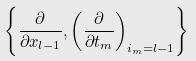<formula> <loc_0><loc_0><loc_500><loc_500>\left \{ \frac { \partial } { \partial x _ { l - 1 } } , \left ( \frac { \partial } { \partial t _ { m } } \right ) _ { i _ { m } = l - 1 } \right \}</formula> 